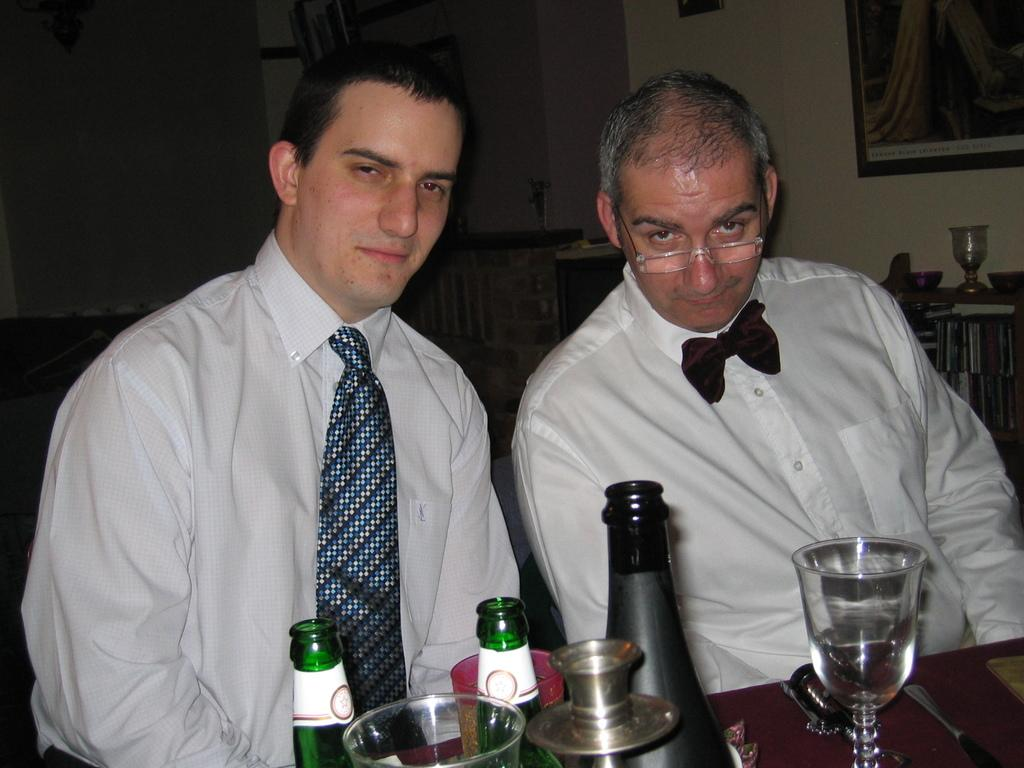How many people are in the image? There are two men in the image. What are the men doing in the image? The men are sitting in front of a table. What can be seen on the table in the image? There are wine bottles on the table. What type of animal is attacking the men in the image? There is no animal present in the image, nor is there any indication of an attack. 